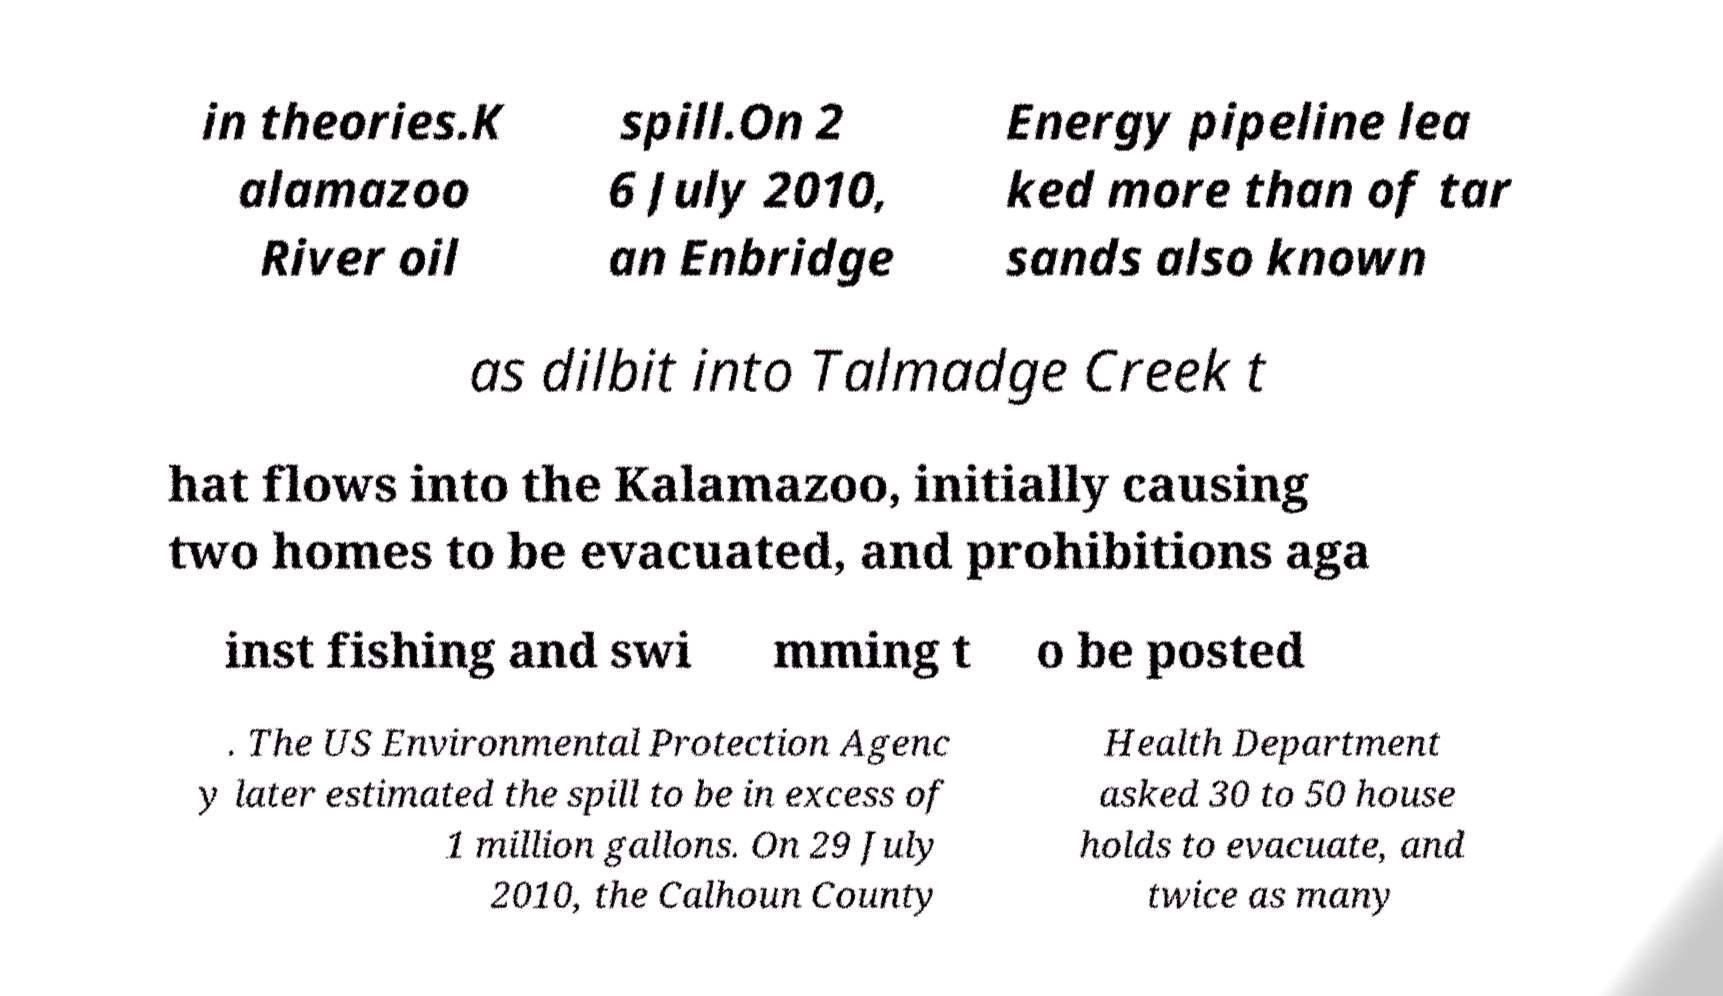Please identify and transcribe the text found in this image. in theories.K alamazoo River oil spill.On 2 6 July 2010, an Enbridge Energy pipeline lea ked more than of tar sands also known as dilbit into Talmadge Creek t hat flows into the Kalamazoo, initially causing two homes to be evacuated, and prohibitions aga inst fishing and swi mming t o be posted . The US Environmental Protection Agenc y later estimated the spill to be in excess of 1 million gallons. On 29 July 2010, the Calhoun County Health Department asked 30 to 50 house holds to evacuate, and twice as many 